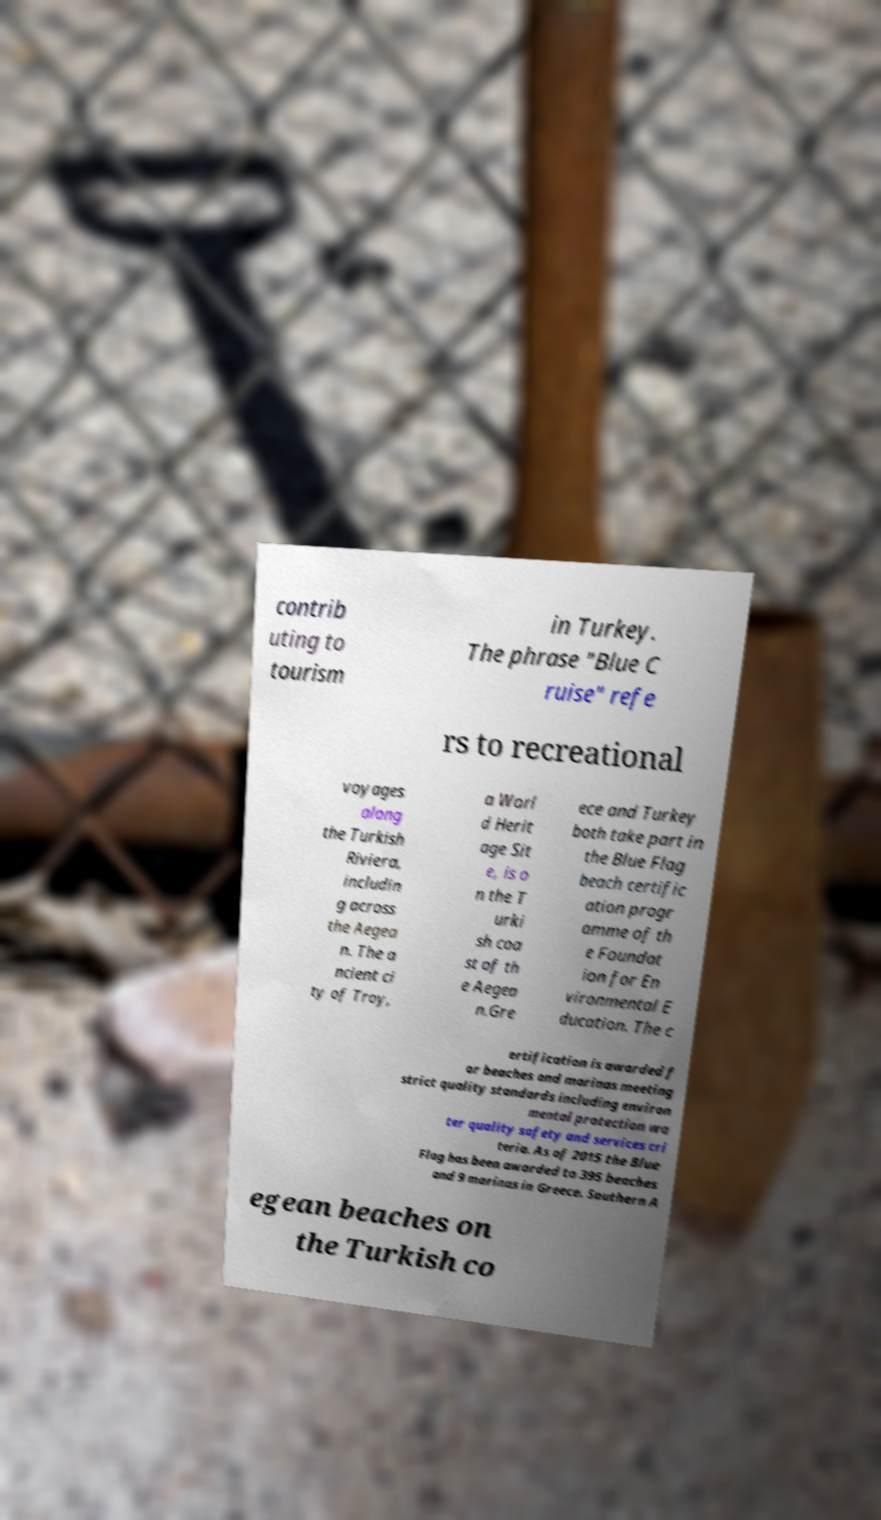Could you extract and type out the text from this image? contrib uting to tourism in Turkey. The phrase "Blue C ruise" refe rs to recreational voyages along the Turkish Riviera, includin g across the Aegea n. The a ncient ci ty of Troy, a Worl d Herit age Sit e, is o n the T urki sh coa st of th e Aegea n.Gre ece and Turkey both take part in the Blue Flag beach certific ation progr amme of th e Foundat ion for En vironmental E ducation. The c ertification is awarded f or beaches and marinas meeting strict quality standards including environ mental protection wa ter quality safety and services cri teria. As of 2015 the Blue Flag has been awarded to 395 beaches and 9 marinas in Greece. Southern A egean beaches on the Turkish co 